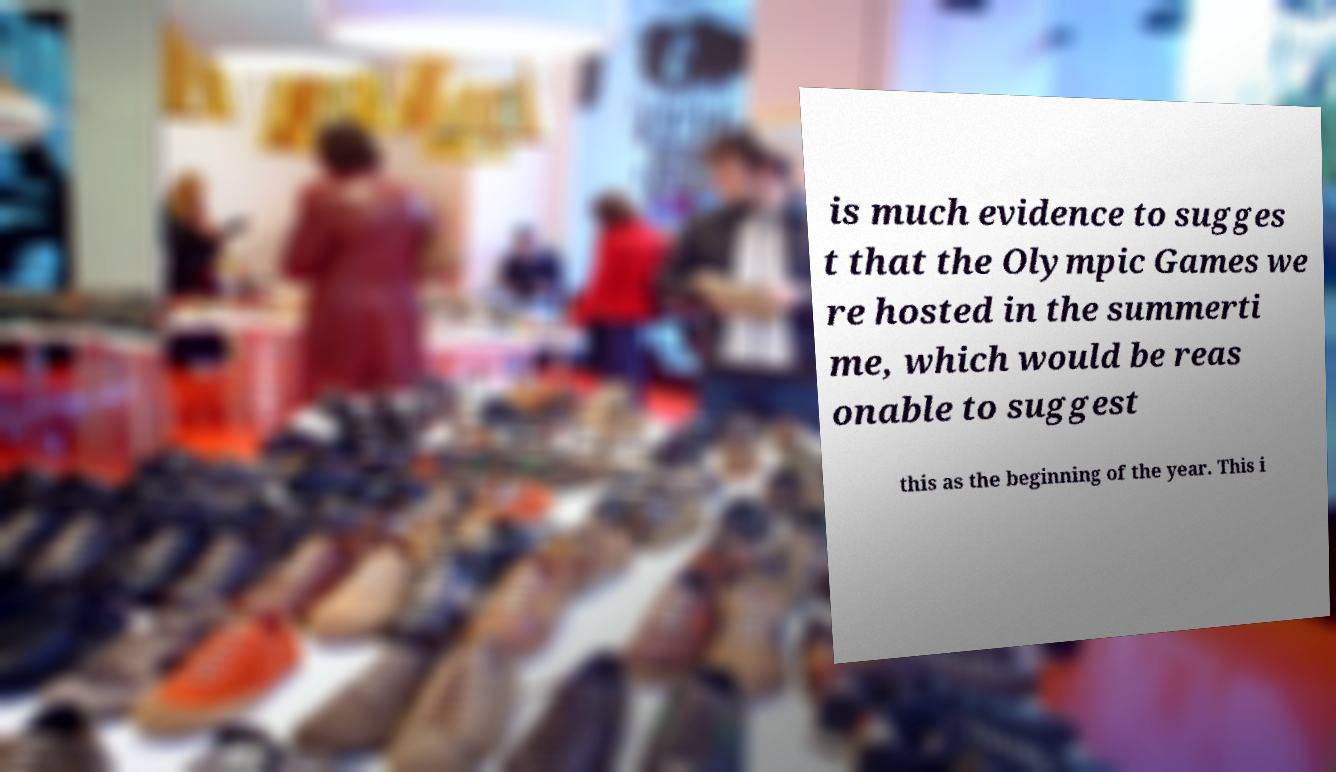Could you assist in decoding the text presented in this image and type it out clearly? is much evidence to sugges t that the Olympic Games we re hosted in the summerti me, which would be reas onable to suggest this as the beginning of the year. This i 